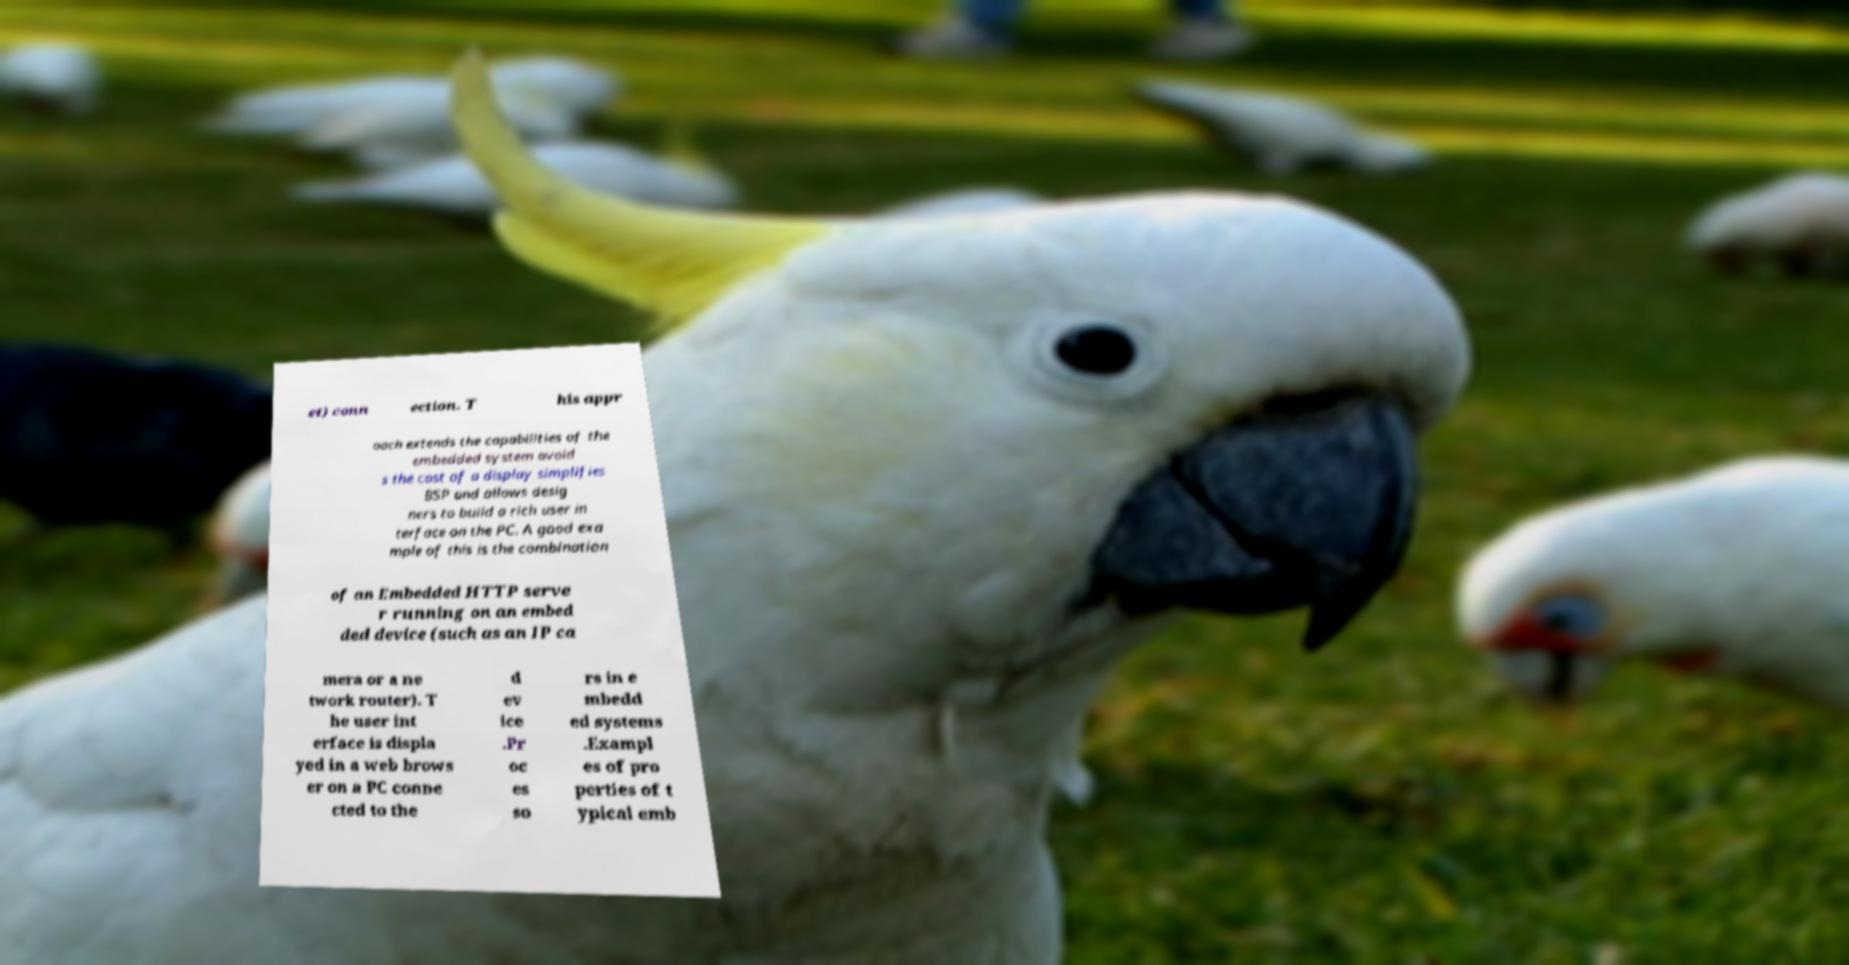Can you accurately transcribe the text from the provided image for me? et) conn ection. T his appr oach extends the capabilities of the embedded system avoid s the cost of a display simplifies BSP and allows desig ners to build a rich user in terface on the PC. A good exa mple of this is the combination of an Embedded HTTP serve r running on an embed ded device (such as an IP ca mera or a ne twork router). T he user int erface is displa yed in a web brows er on a PC conne cted to the d ev ice .Pr oc es so rs in e mbedd ed systems .Exampl es of pro perties of t ypical emb 